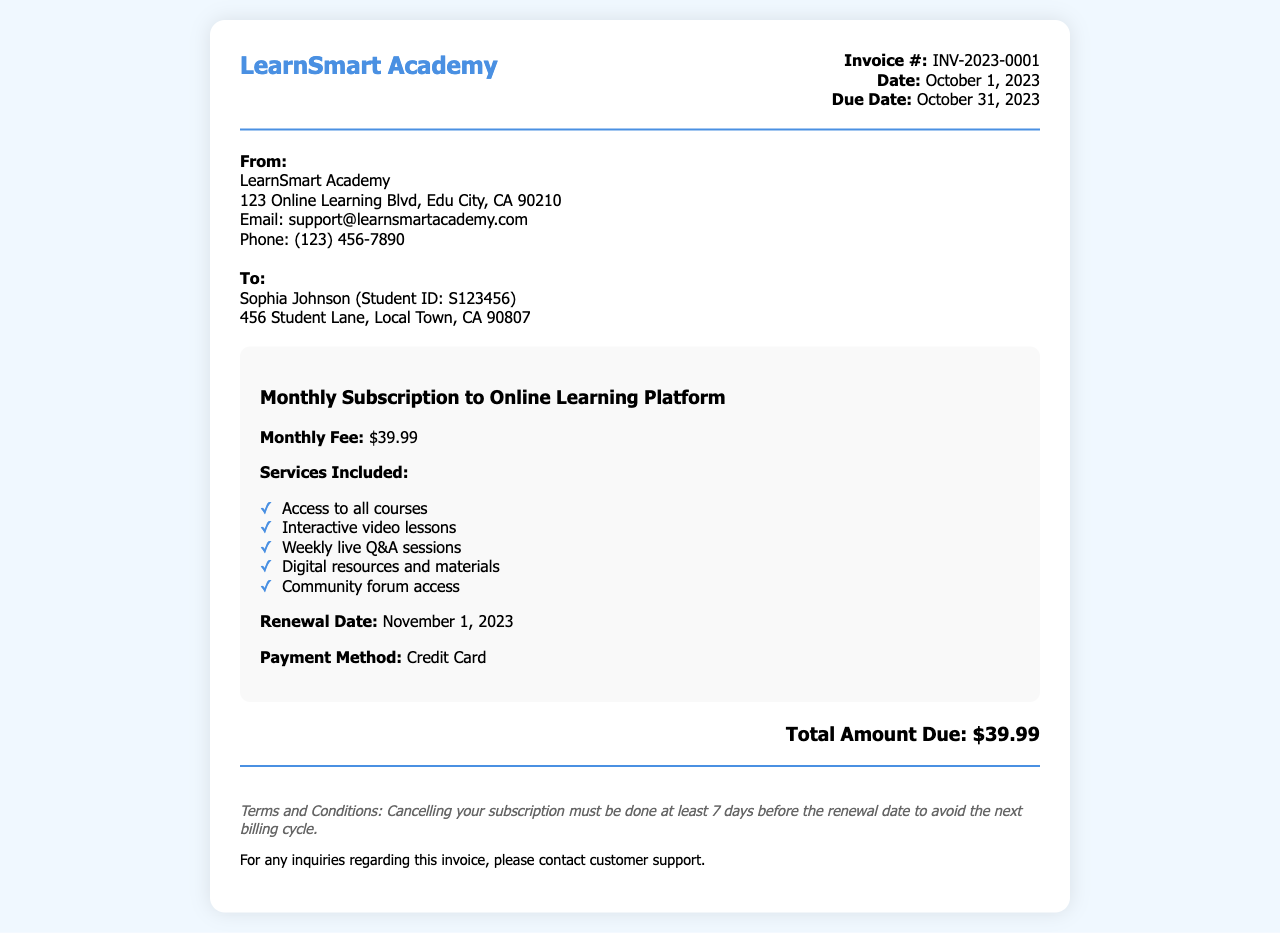What is the invoice number? The invoice number is listed at the top right corner of the document under Invoice #:
Answer: INV-2023-0001 Who is the recipient of this invoice? The recipient's information is provided in the address block, stating the name and Student ID under "To:".
Answer: Sophia Johnson What is the monthly fee for the subscription? The monthly fee is specified in the subscription details section under "Monthly Fee:".
Answer: $39.99 When is the due date for this invoice? The due date is mentioned in the invoice details under "Due Date:".
Answer: October 31, 2023 What services are included in the subscription? The services are listed in the subscription details section as a bulleted list.
Answer: Access to all courses, Interactive video lessons, Weekly live Q&A sessions, Digital resources and materials, Community forum access What is the renewal date for the subscription? The renewal date is given in the subscription details section under "Renewal Date:".
Answer: November 1, 2023 What payment method was used for this invoice? The payment method is indicated in the subscription details section under "Payment Method:".
Answer: Credit Card What is the total amount due? The total amount due is displayed in a prominent section labeled "Total Amount Due:".
Answer: $39.99 What are the terms for cancelling the subscription? The cancellation terms are found in the footer section under "Terms and Conditions:".
Answer: Cancelling your subscription must be done at least 7 days before the renewal date 